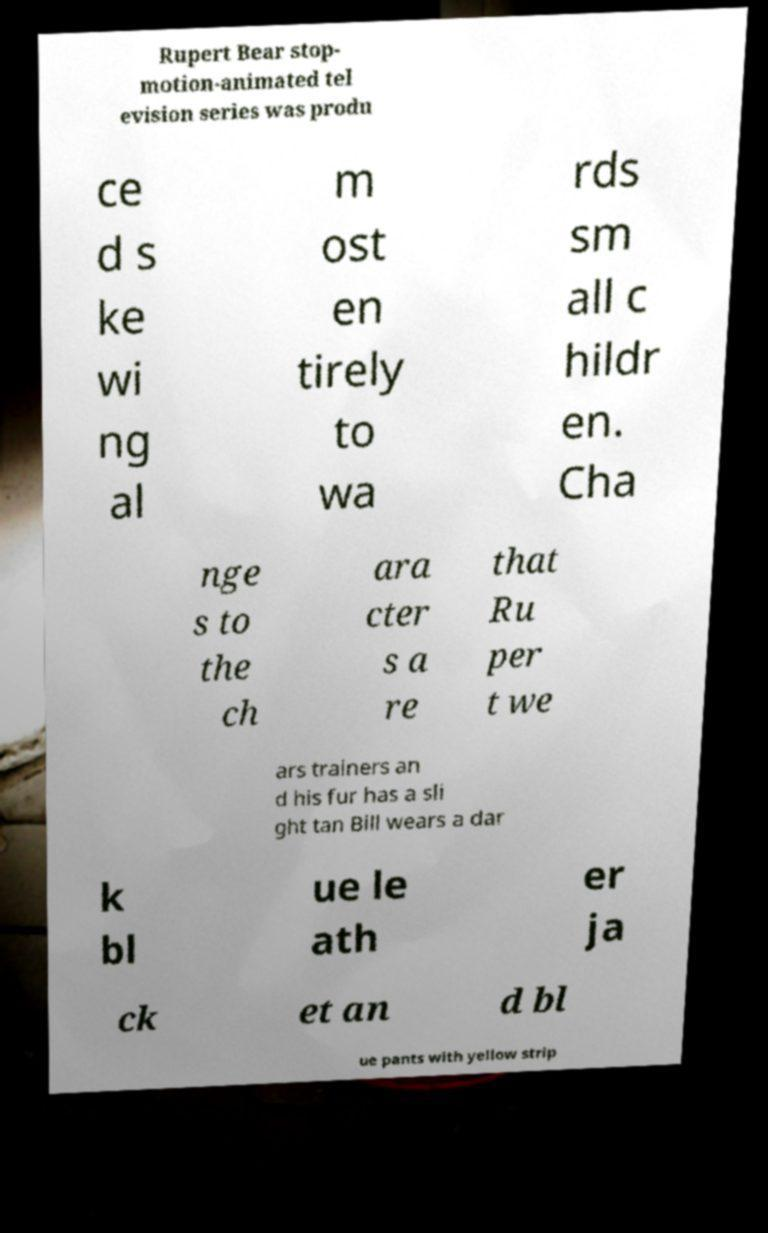There's text embedded in this image that I need extracted. Can you transcribe it verbatim? Rupert Bear stop- motion-animated tel evision series was produ ce d s ke wi ng al m ost en tirely to wa rds sm all c hildr en. Cha nge s to the ch ara cter s a re that Ru per t we ars trainers an d his fur has a sli ght tan Bill wears a dar k bl ue le ath er ja ck et an d bl ue pants with yellow strip 